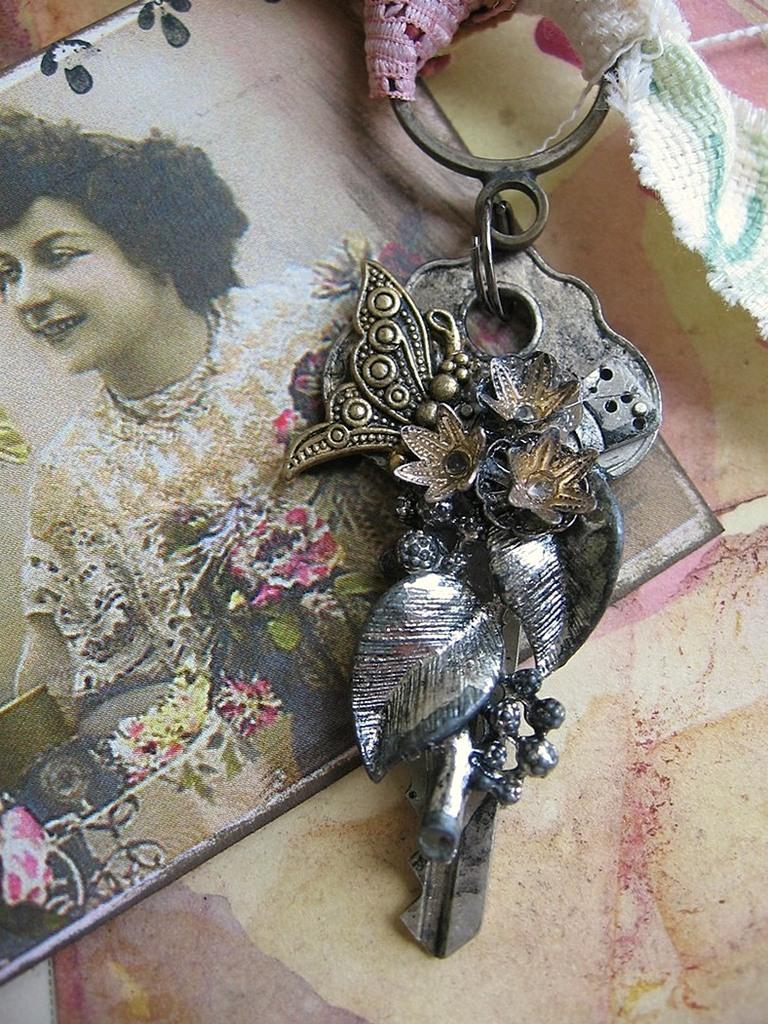What is the main subject of the image? There is a photo of a woman in the image. What other object can be seen in the image? There is a keychain present in the image. What direction is the tiger facing in the image? There is no tiger present in the image. What type of vest is the woman wearing in the photo? The provided facts do not mention any clothing or accessories worn by the woman in the photo. 